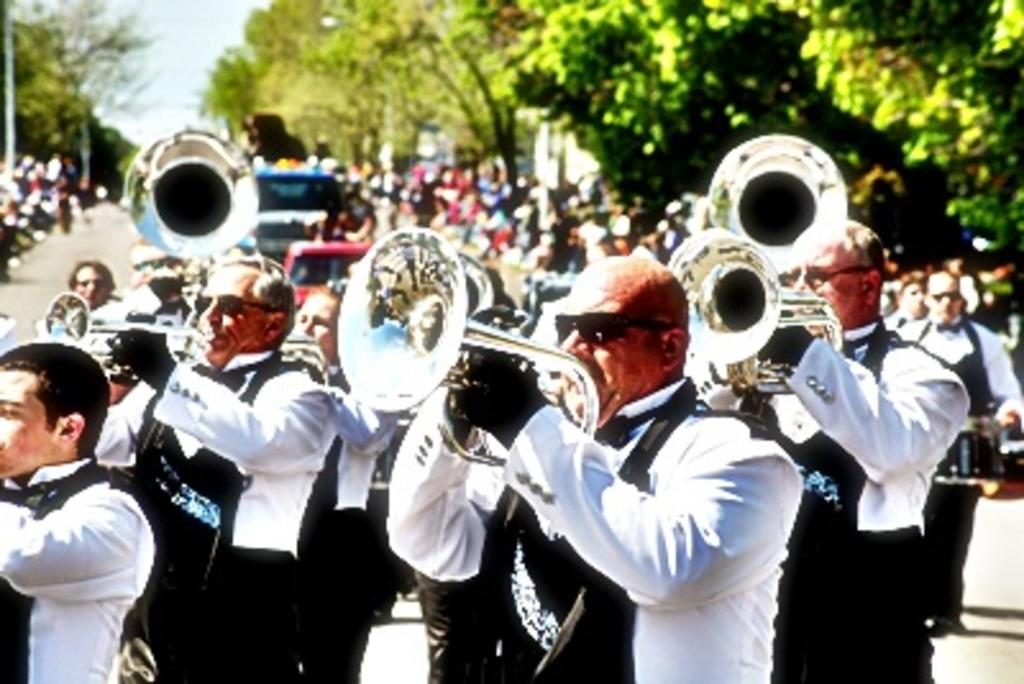What are the men in the image doing? The men in the image are playing instruments. Can you describe the setting in which the men are playing? There is a huge crowd behind the group of men, and there are many trees around the crowd. What type of silver object can be seen on the hill in the image? There is no hill or silver object present in the image. How many trains are visible in the image? There are no trains visible in the image. 